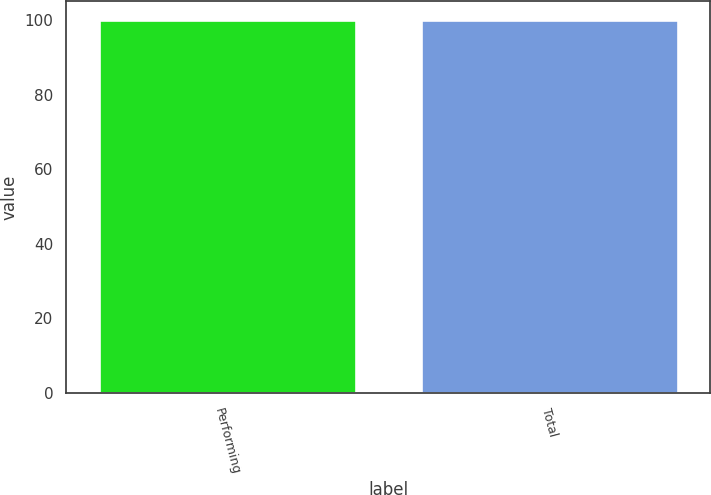<chart> <loc_0><loc_0><loc_500><loc_500><bar_chart><fcel>Performing<fcel>Total<nl><fcel>100<fcel>100.1<nl></chart> 